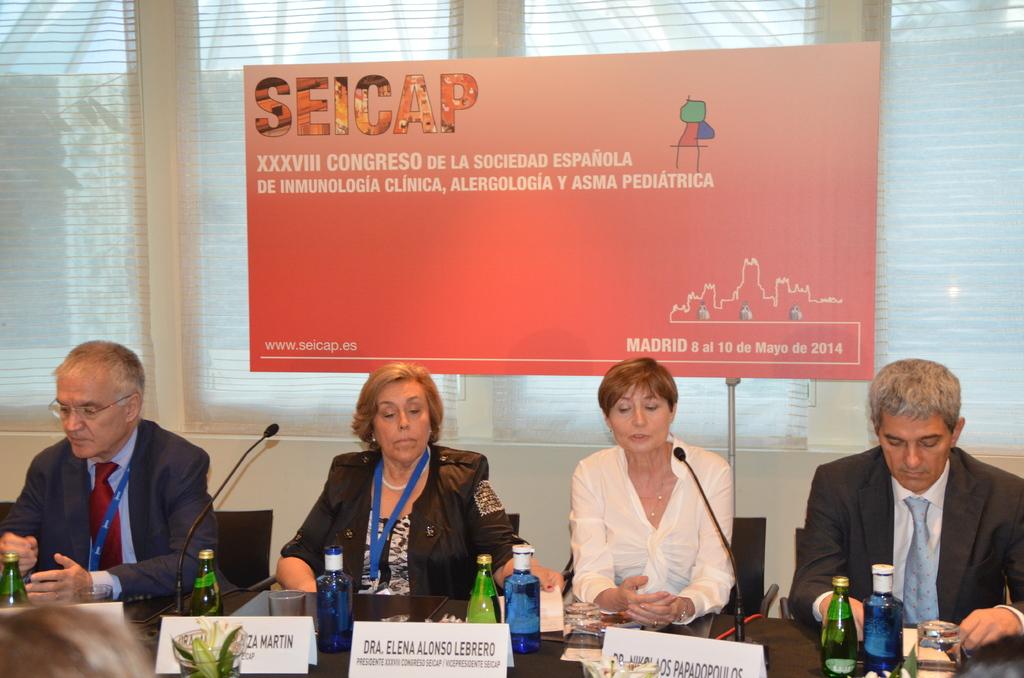What year is on the sign?
Your response must be concise. 2014. 